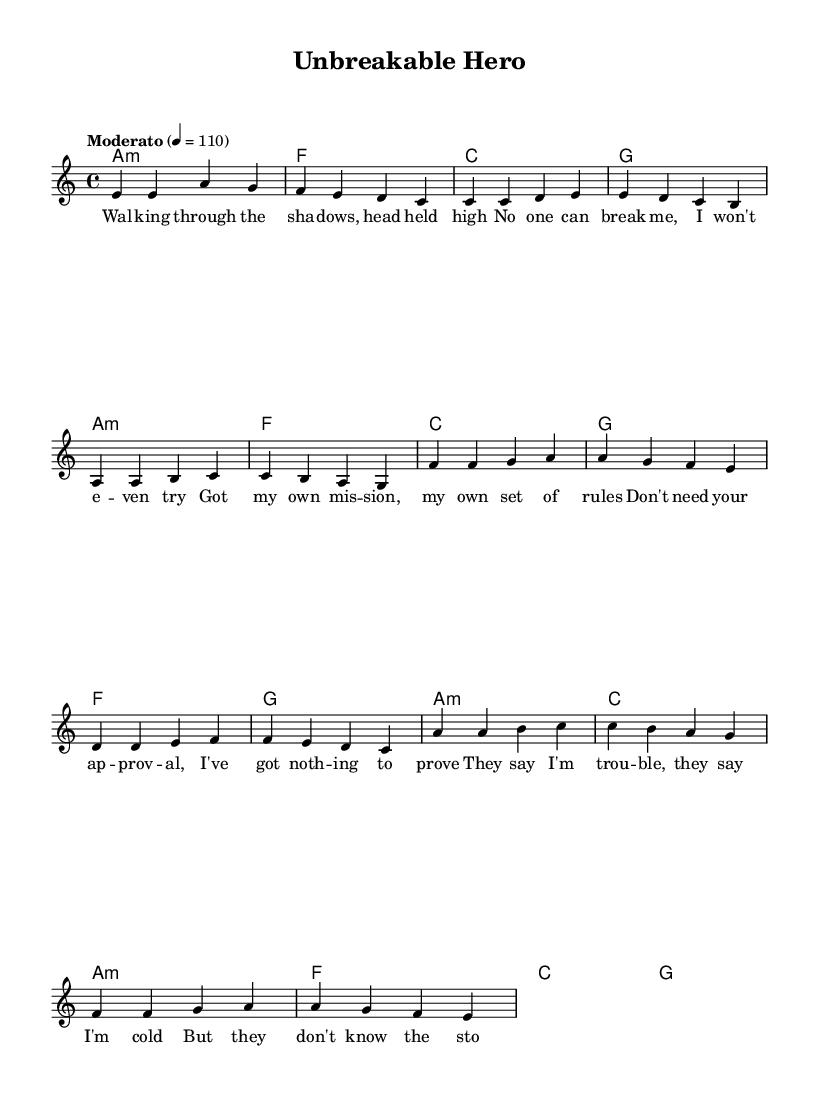What is the key signature of this music? The key signature is indicated at the beginning of the music sheet, showing the note A with no sharps or flats. This means it is in A minor.
Answer: A minor What is the time signature of the piece? The time signature appears at the beginning, represented as 4/4, indicating four beats in a measure.
Answer: 4/4 What is the tempo marking for this piece? The tempo marking is found at the start of the melody and indicates the piece should be played "Moderato" at a speed of 110 beats per minute.
Answer: Moderato, 110 How many sections are present in the lyrics? By analyzing the lyric structure, we see three distinct sections: verse, pre-chorus, and chorus, making a total of three sections.
Answer: Three What is the emotional theme conveyed in the chorus lyrics? The chorus lyrics express themes of empowerment and resilience, emphasizing being unbreakable and fighting through adversity. This is consistent with strong female protagonist imagery in K-Pop.
Answer: Empowerment What type of harmony is used in the introduction? The introduction consists of a minor chord followed by other major chords, indicating a solid harmonic foundation typical of K-Pop music.
Answer: Minor and major chords What is the motivation expressed in the verse lyrics? The verse lyrics convey a sense of independence and self-assertion, where the protagonist claims their own rules and doesn't seek validation from others.
Answer: Independence and self-assertion 